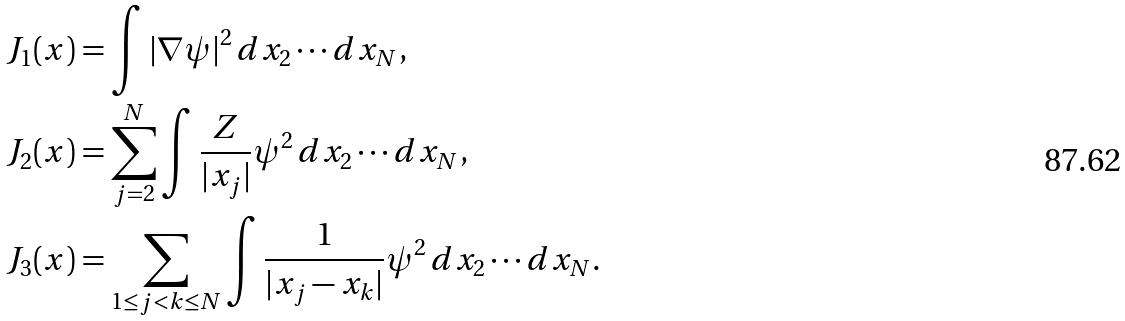Convert formula to latex. <formula><loc_0><loc_0><loc_500><loc_500>J _ { 1 } ( x ) & = \int | \nabla \psi | ^ { 2 } \, d x _ { 2 } \cdots d x _ { N } , \\ J _ { 2 } ( x ) & = \sum _ { j = 2 } ^ { N } \int \frac { Z } { | x _ { j } | } \psi ^ { 2 } \, d x _ { 2 } \cdots d x _ { N } , \\ J _ { 3 } ( x ) & = \sum _ { 1 \leq j < k \leq N } \int \frac { 1 } { | x _ { j } - x _ { k } | } \psi ^ { 2 } \, d x _ { 2 } \cdots d x _ { N } .</formula> 